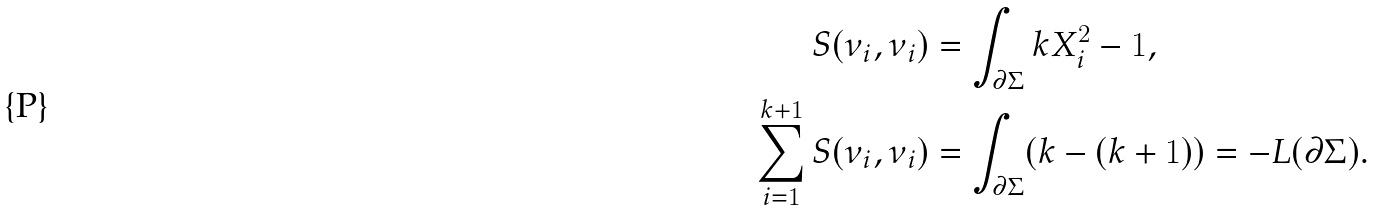Convert formula to latex. <formula><loc_0><loc_0><loc_500><loc_500>S ( \nu _ { i } , \nu _ { i } ) & = \int _ { \partial \Sigma } k X _ { i } ^ { 2 } - 1 , \\ \sum _ { i = 1 } ^ { k + 1 } S ( \nu _ { i } , \nu _ { i } ) & = \int _ { \partial \Sigma } ( k - ( k + 1 ) ) = - L ( \partial \Sigma ) .</formula> 